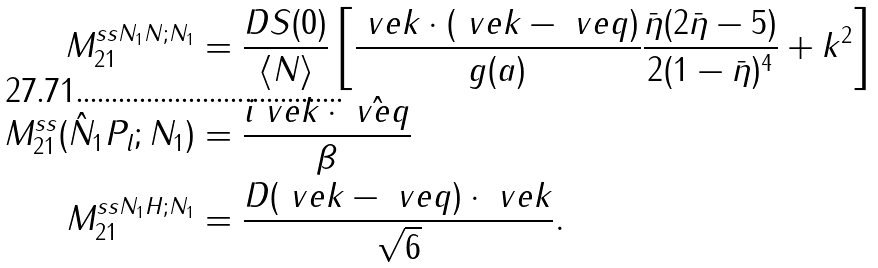<formula> <loc_0><loc_0><loc_500><loc_500>M _ { 2 1 } ^ { s s N _ { 1 } N ; N _ { 1 } } & = \frac { D S ( 0 ) } { \langle N \rangle } \left [ \frac { \ v e k \cdot ( \ v e k - \ v e q ) } { g ( a ) } \frac { \bar { \eta } ( 2 \bar { \eta } - 5 ) } { 2 ( 1 - \bar { \eta } ) ^ { 4 } } + k ^ { 2 } \right ] \\ M _ { 2 1 } ^ { s s } ( \hat { N } _ { 1 } P _ { l } ; N _ { 1 } ) & = \frac { i \ v e k \cdot \hat { \ v e q } } { \beta } \\ M _ { 2 1 } ^ { s s N _ { 1 } H ; N _ { 1 } } & = \frac { D ( \ v e k - \ v e q ) \cdot \ v e k } { \sqrt { 6 } } .</formula> 